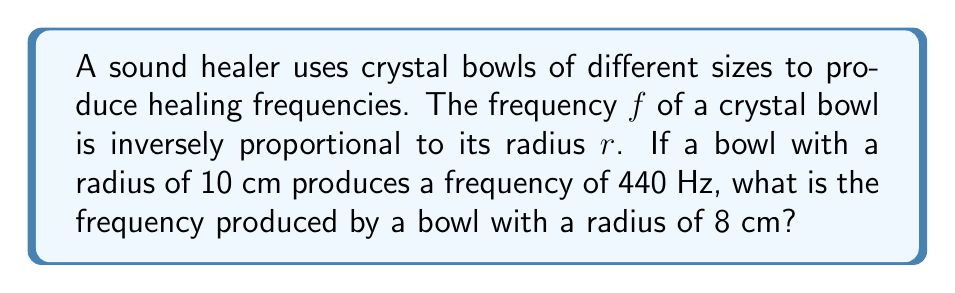Solve this math problem. Let's approach this step-by-step:

1) We're told that the frequency $f$ is inversely proportional to the radius $r$. This can be expressed mathematically as:

   $$f \propto \frac{1}{r}$$

2) This proportionality can be turned into an equation by introducing a constant $k$:

   $$f = \frac{k}{r}$$

3) We can find the value of $k$ using the given information for the first bowl:
   
   When $r_1 = 10$ cm, $f_1 = 440$ Hz

   $$440 = \frac{k}{10}$$
   $$k = 440 \cdot 10 = 4400$$

4) Now that we know $k$, we can use it to find the frequency of the second bowl:

   $$f_2 = \frac{k}{r_2} = \frac{4400}{8}$$

5) Calculating this:

   $$f_2 = 550 \text{ Hz}$$
Answer: 550 Hz 